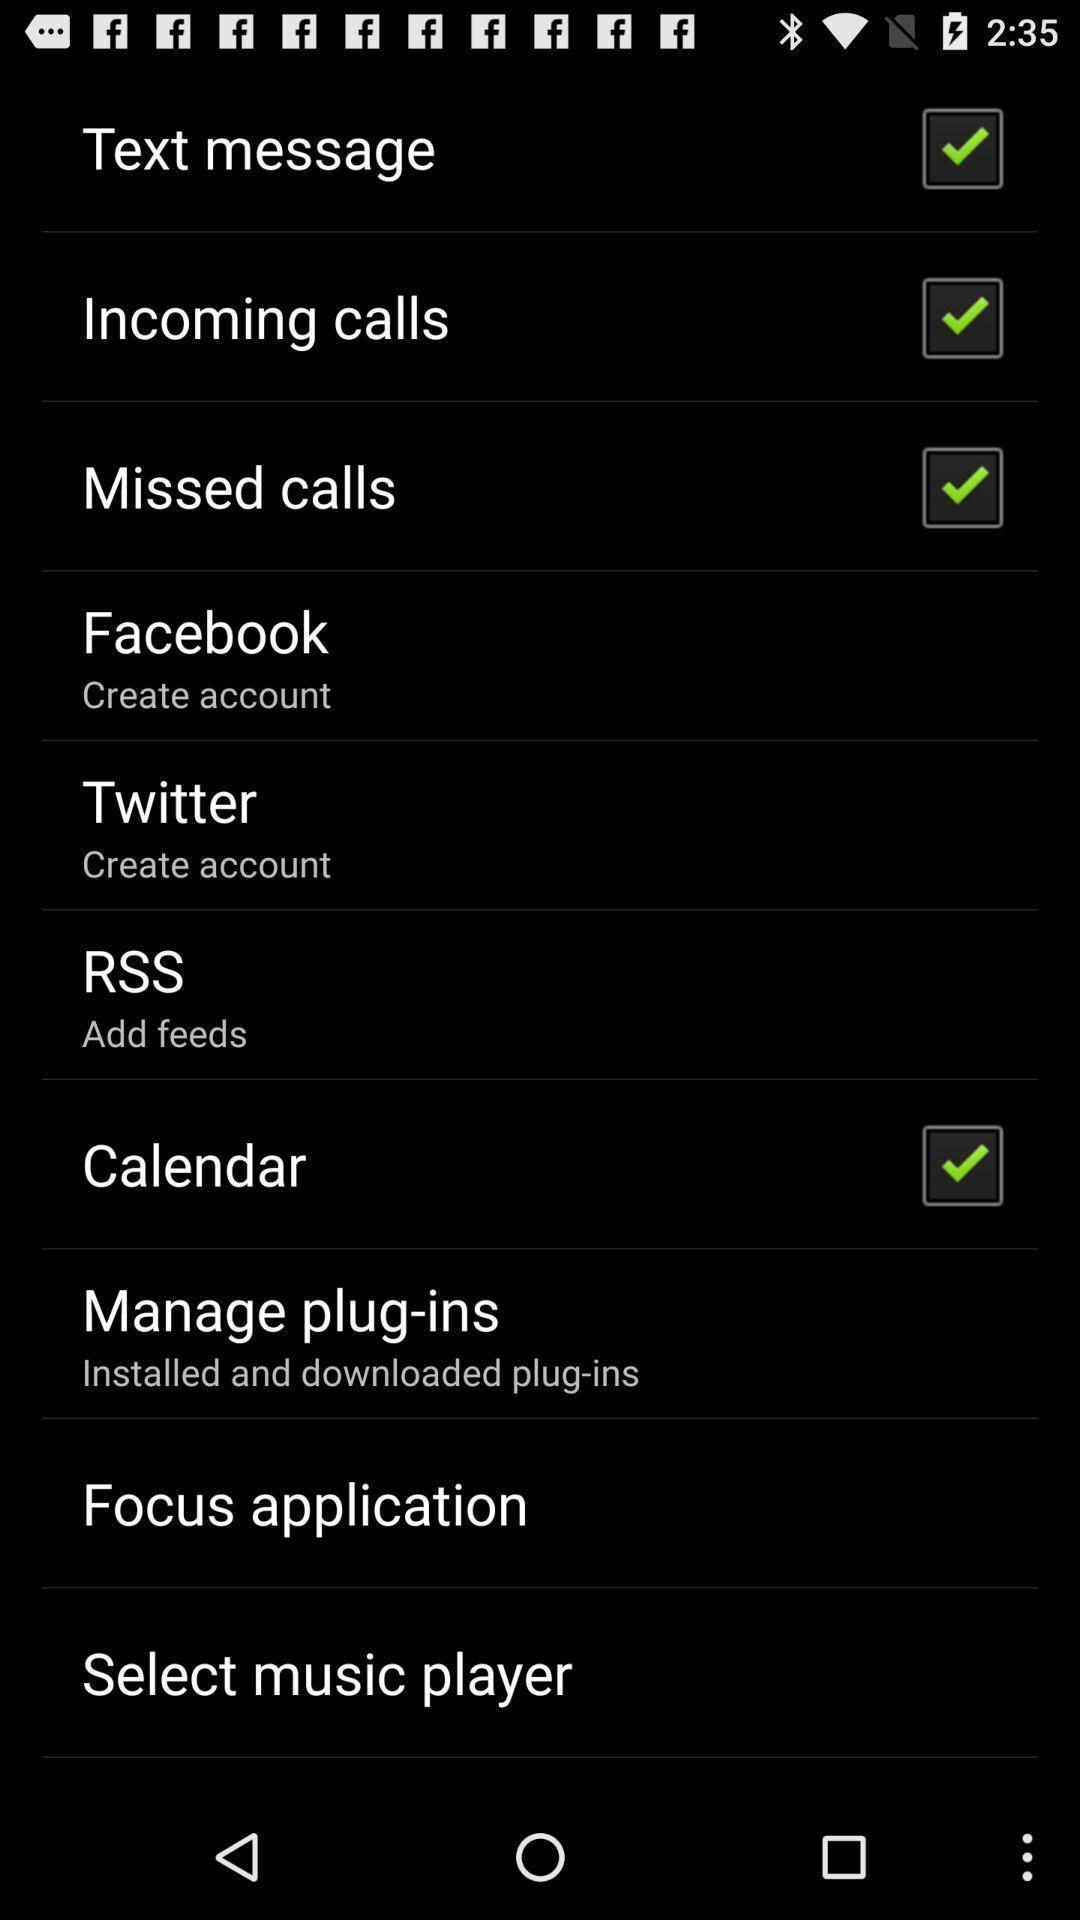Please provide a description for this image. Screen display list of various options. 